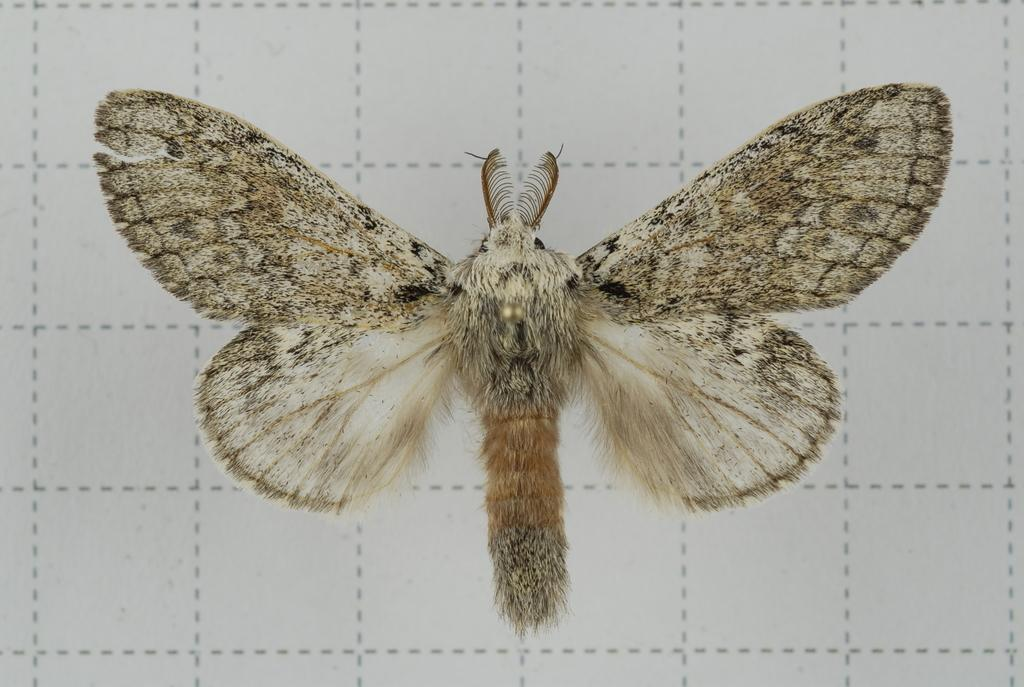What is the main subject of the image? There is a butterfly in the image. Can you describe the background of the image? The background of the image is white with dotted lines. Where is the snail located in the image? There is no snail present in the image. What type of bottle can be seen on top of the butterfly in the image? There is no bottle present in the image, and the butterfly is not on top of anything. 